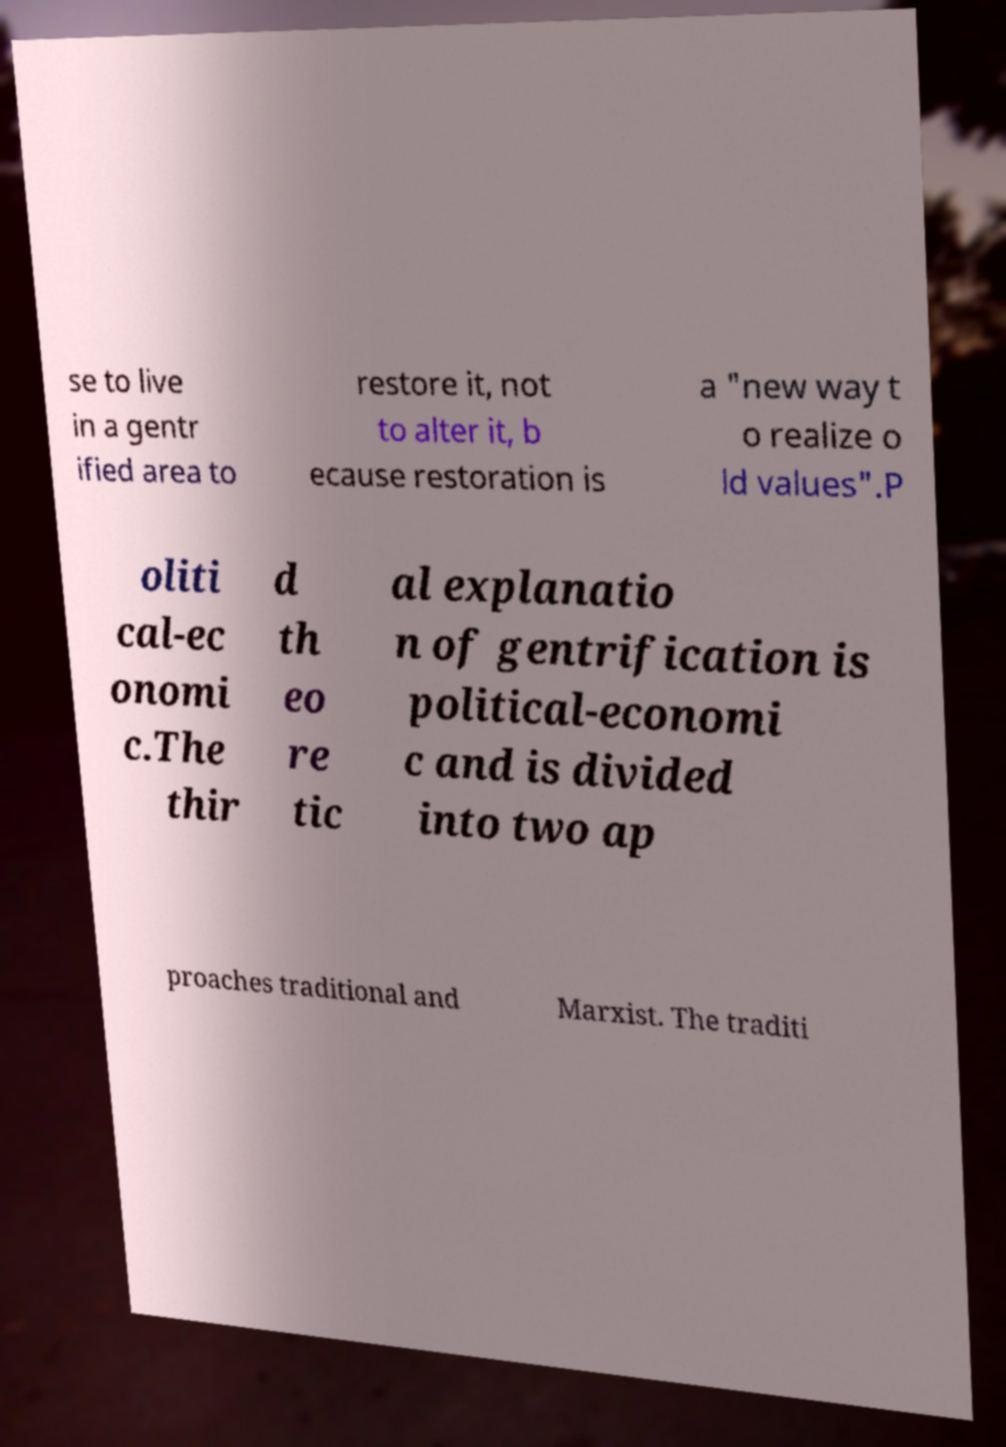There's text embedded in this image that I need extracted. Can you transcribe it verbatim? se to live in a gentr ified area to restore it, not to alter it, b ecause restoration is a "new way t o realize o ld values".P oliti cal-ec onomi c.The thir d th eo re tic al explanatio n of gentrification is political-economi c and is divided into two ap proaches traditional and Marxist. The traditi 